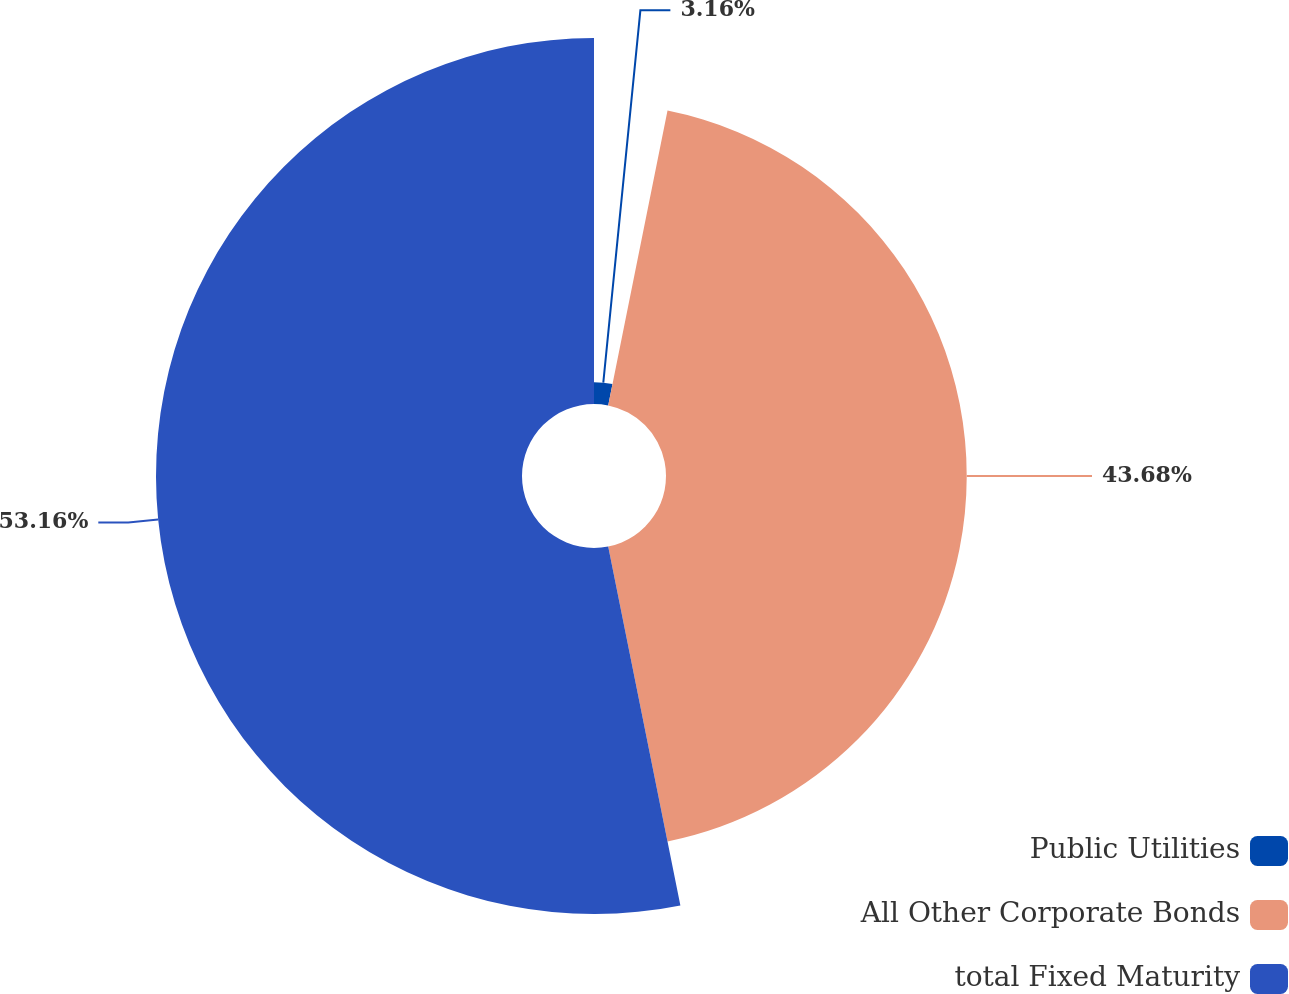<chart> <loc_0><loc_0><loc_500><loc_500><pie_chart><fcel>Public Utilities<fcel>All Other Corporate Bonds<fcel>total Fixed Maturity<nl><fcel>3.16%<fcel>43.68%<fcel>53.16%<nl></chart> 